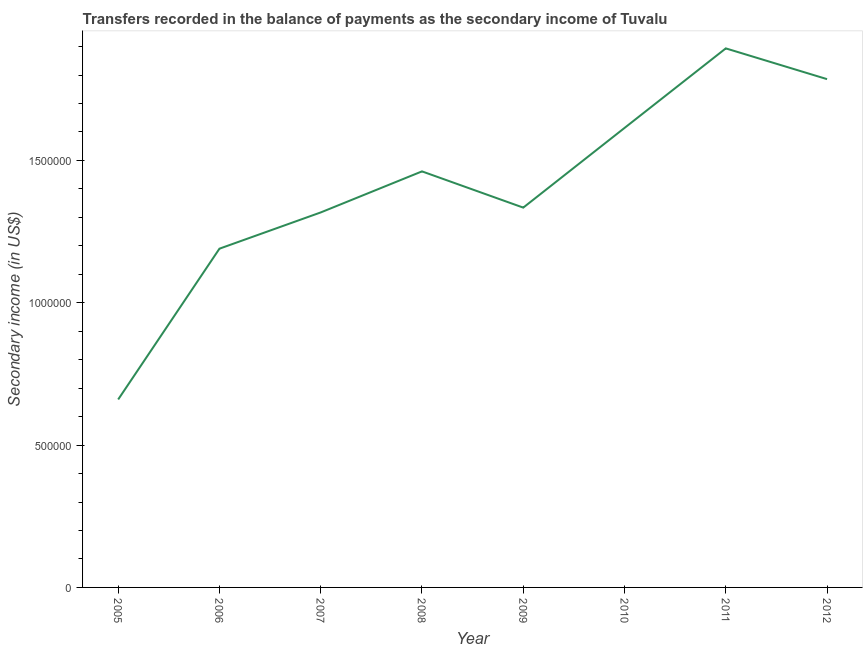What is the amount of secondary income in 2011?
Ensure brevity in your answer.  1.89e+06. Across all years, what is the maximum amount of secondary income?
Your answer should be compact. 1.89e+06. Across all years, what is the minimum amount of secondary income?
Provide a short and direct response. 6.60e+05. In which year was the amount of secondary income maximum?
Provide a succinct answer. 2011. What is the sum of the amount of secondary income?
Your answer should be very brief. 1.13e+07. What is the difference between the amount of secondary income in 2005 and 2007?
Keep it short and to the point. -6.57e+05. What is the average amount of secondary income per year?
Offer a terse response. 1.41e+06. What is the median amount of secondary income?
Make the answer very short. 1.40e+06. In how many years, is the amount of secondary income greater than 800000 US$?
Make the answer very short. 7. What is the ratio of the amount of secondary income in 2006 to that in 2009?
Ensure brevity in your answer.  0.89. Is the difference between the amount of secondary income in 2008 and 2010 greater than the difference between any two years?
Your answer should be very brief. No. What is the difference between the highest and the second highest amount of secondary income?
Your answer should be very brief. 1.08e+05. What is the difference between the highest and the lowest amount of secondary income?
Ensure brevity in your answer.  1.23e+06. In how many years, is the amount of secondary income greater than the average amount of secondary income taken over all years?
Provide a short and direct response. 4. Does the amount of secondary income monotonically increase over the years?
Ensure brevity in your answer.  No. How many lines are there?
Offer a terse response. 1. How many years are there in the graph?
Offer a very short reply. 8. What is the difference between two consecutive major ticks on the Y-axis?
Offer a very short reply. 5.00e+05. Does the graph contain grids?
Offer a terse response. No. What is the title of the graph?
Provide a short and direct response. Transfers recorded in the balance of payments as the secondary income of Tuvalu. What is the label or title of the X-axis?
Give a very brief answer. Year. What is the label or title of the Y-axis?
Ensure brevity in your answer.  Secondary income (in US$). What is the Secondary income (in US$) of 2005?
Offer a terse response. 6.60e+05. What is the Secondary income (in US$) of 2006?
Your response must be concise. 1.19e+06. What is the Secondary income (in US$) of 2007?
Your answer should be compact. 1.32e+06. What is the Secondary income (in US$) of 2008?
Make the answer very short. 1.46e+06. What is the Secondary income (in US$) in 2009?
Give a very brief answer. 1.33e+06. What is the Secondary income (in US$) of 2010?
Your answer should be very brief. 1.61e+06. What is the Secondary income (in US$) of 2011?
Your answer should be very brief. 1.89e+06. What is the Secondary income (in US$) of 2012?
Give a very brief answer. 1.79e+06. What is the difference between the Secondary income (in US$) in 2005 and 2006?
Make the answer very short. -5.30e+05. What is the difference between the Secondary income (in US$) in 2005 and 2007?
Provide a short and direct response. -6.57e+05. What is the difference between the Secondary income (in US$) in 2005 and 2008?
Give a very brief answer. -8.01e+05. What is the difference between the Secondary income (in US$) in 2005 and 2009?
Provide a succinct answer. -6.74e+05. What is the difference between the Secondary income (in US$) in 2005 and 2010?
Your answer should be compact. -9.54e+05. What is the difference between the Secondary income (in US$) in 2005 and 2011?
Your answer should be very brief. -1.23e+06. What is the difference between the Secondary income (in US$) in 2005 and 2012?
Your response must be concise. -1.13e+06. What is the difference between the Secondary income (in US$) in 2006 and 2007?
Your response must be concise. -1.27e+05. What is the difference between the Secondary income (in US$) in 2006 and 2008?
Offer a very short reply. -2.72e+05. What is the difference between the Secondary income (in US$) in 2006 and 2009?
Your answer should be compact. -1.44e+05. What is the difference between the Secondary income (in US$) in 2006 and 2010?
Keep it short and to the point. -4.24e+05. What is the difference between the Secondary income (in US$) in 2006 and 2011?
Your answer should be very brief. -7.04e+05. What is the difference between the Secondary income (in US$) in 2006 and 2012?
Provide a short and direct response. -5.96e+05. What is the difference between the Secondary income (in US$) in 2007 and 2008?
Offer a terse response. -1.44e+05. What is the difference between the Secondary income (in US$) in 2007 and 2009?
Provide a short and direct response. -1.69e+04. What is the difference between the Secondary income (in US$) in 2007 and 2010?
Offer a terse response. -2.97e+05. What is the difference between the Secondary income (in US$) in 2007 and 2011?
Provide a short and direct response. -5.76e+05. What is the difference between the Secondary income (in US$) in 2007 and 2012?
Provide a short and direct response. -4.68e+05. What is the difference between the Secondary income (in US$) in 2008 and 2009?
Give a very brief answer. 1.27e+05. What is the difference between the Secondary income (in US$) in 2008 and 2010?
Your response must be concise. -1.53e+05. What is the difference between the Secondary income (in US$) in 2008 and 2011?
Offer a very short reply. -4.32e+05. What is the difference between the Secondary income (in US$) in 2008 and 2012?
Your response must be concise. -3.24e+05. What is the difference between the Secondary income (in US$) in 2009 and 2010?
Provide a short and direct response. -2.80e+05. What is the difference between the Secondary income (in US$) in 2009 and 2011?
Offer a very short reply. -5.59e+05. What is the difference between the Secondary income (in US$) in 2009 and 2012?
Your response must be concise. -4.51e+05. What is the difference between the Secondary income (in US$) in 2010 and 2011?
Ensure brevity in your answer.  -2.80e+05. What is the difference between the Secondary income (in US$) in 2010 and 2012?
Your response must be concise. -1.71e+05. What is the difference between the Secondary income (in US$) in 2011 and 2012?
Offer a terse response. 1.08e+05. What is the ratio of the Secondary income (in US$) in 2005 to that in 2006?
Make the answer very short. 0.56. What is the ratio of the Secondary income (in US$) in 2005 to that in 2007?
Ensure brevity in your answer.  0.5. What is the ratio of the Secondary income (in US$) in 2005 to that in 2008?
Provide a succinct answer. 0.45. What is the ratio of the Secondary income (in US$) in 2005 to that in 2009?
Give a very brief answer. 0.49. What is the ratio of the Secondary income (in US$) in 2005 to that in 2010?
Make the answer very short. 0.41. What is the ratio of the Secondary income (in US$) in 2005 to that in 2011?
Keep it short and to the point. 0.35. What is the ratio of the Secondary income (in US$) in 2005 to that in 2012?
Your response must be concise. 0.37. What is the ratio of the Secondary income (in US$) in 2006 to that in 2007?
Offer a terse response. 0.9. What is the ratio of the Secondary income (in US$) in 2006 to that in 2008?
Keep it short and to the point. 0.81. What is the ratio of the Secondary income (in US$) in 2006 to that in 2009?
Offer a very short reply. 0.89. What is the ratio of the Secondary income (in US$) in 2006 to that in 2010?
Make the answer very short. 0.74. What is the ratio of the Secondary income (in US$) in 2006 to that in 2011?
Offer a very short reply. 0.63. What is the ratio of the Secondary income (in US$) in 2006 to that in 2012?
Provide a short and direct response. 0.67. What is the ratio of the Secondary income (in US$) in 2007 to that in 2008?
Provide a short and direct response. 0.9. What is the ratio of the Secondary income (in US$) in 2007 to that in 2010?
Provide a short and direct response. 0.82. What is the ratio of the Secondary income (in US$) in 2007 to that in 2011?
Ensure brevity in your answer.  0.7. What is the ratio of the Secondary income (in US$) in 2007 to that in 2012?
Provide a succinct answer. 0.74. What is the ratio of the Secondary income (in US$) in 2008 to that in 2009?
Your answer should be compact. 1.09. What is the ratio of the Secondary income (in US$) in 2008 to that in 2010?
Give a very brief answer. 0.91. What is the ratio of the Secondary income (in US$) in 2008 to that in 2011?
Your response must be concise. 0.77. What is the ratio of the Secondary income (in US$) in 2008 to that in 2012?
Your answer should be very brief. 0.82. What is the ratio of the Secondary income (in US$) in 2009 to that in 2010?
Your response must be concise. 0.83. What is the ratio of the Secondary income (in US$) in 2009 to that in 2011?
Provide a short and direct response. 0.7. What is the ratio of the Secondary income (in US$) in 2009 to that in 2012?
Your response must be concise. 0.75. What is the ratio of the Secondary income (in US$) in 2010 to that in 2011?
Offer a very short reply. 0.85. What is the ratio of the Secondary income (in US$) in 2010 to that in 2012?
Your response must be concise. 0.9. What is the ratio of the Secondary income (in US$) in 2011 to that in 2012?
Your answer should be very brief. 1.06. 